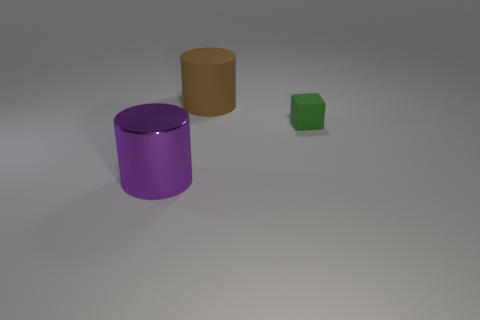Add 1 small metallic cylinders. How many objects exist? 4 Subtract all cylinders. How many objects are left? 1 Subtract all purple cylinders. Subtract all brown cylinders. How many objects are left? 1 Add 1 small blocks. How many small blocks are left? 2 Add 1 large purple matte objects. How many large purple matte objects exist? 1 Subtract 0 red spheres. How many objects are left? 3 